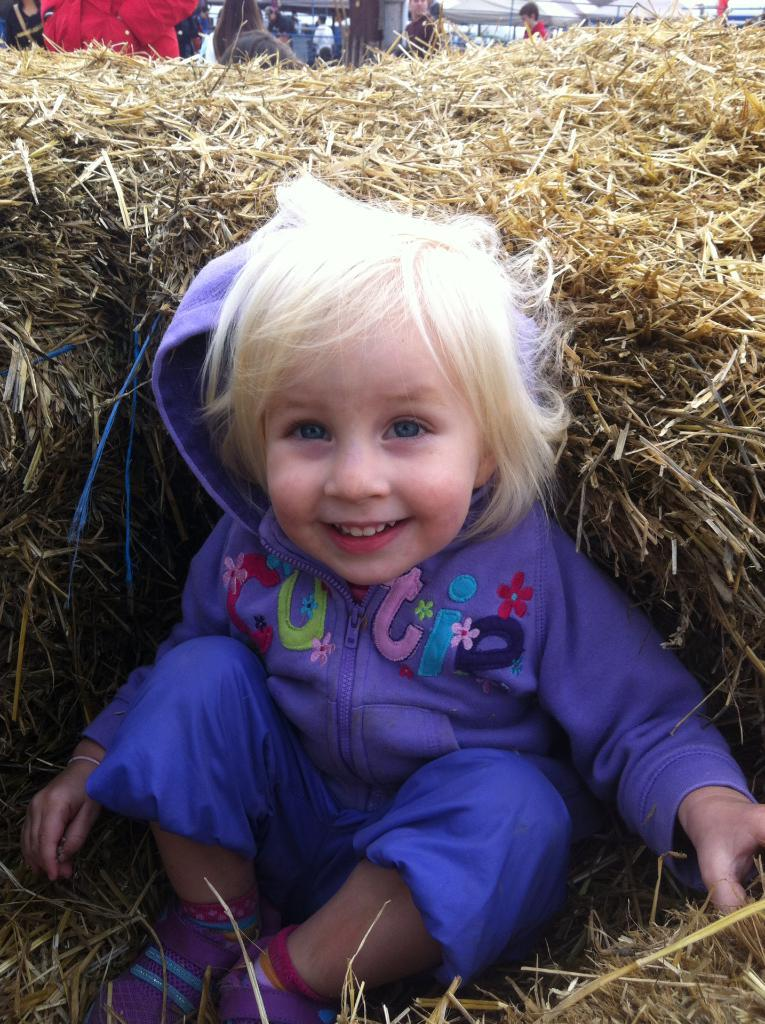What is the main subject of the image? The main subject of the image is a kid. What type of environment is depicted in the image? There is dry grass in the image, suggesting an outdoor setting. Are there any other people in the image besides the kid? Yes, there are people in the image. What type of temporary shelter can be seen in the image? There are tents in the image. What type of wine is being served in the image? There is no wine present in the image. What type of lace is used to decorate the tents in the image? There is no lace visible on the tents in the image. 